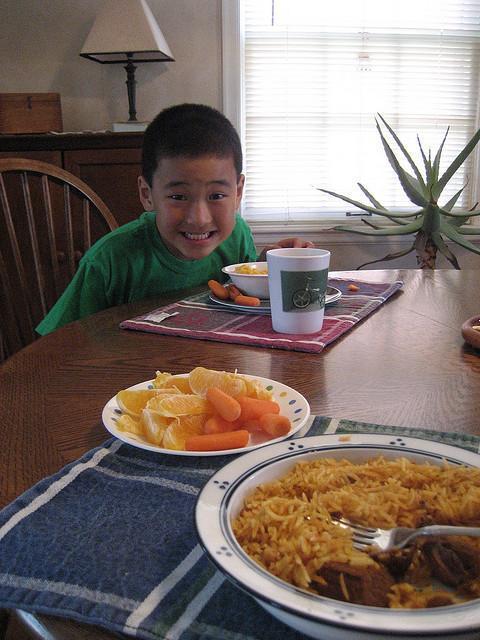How many dining tables are there?
Give a very brief answer. 1. 